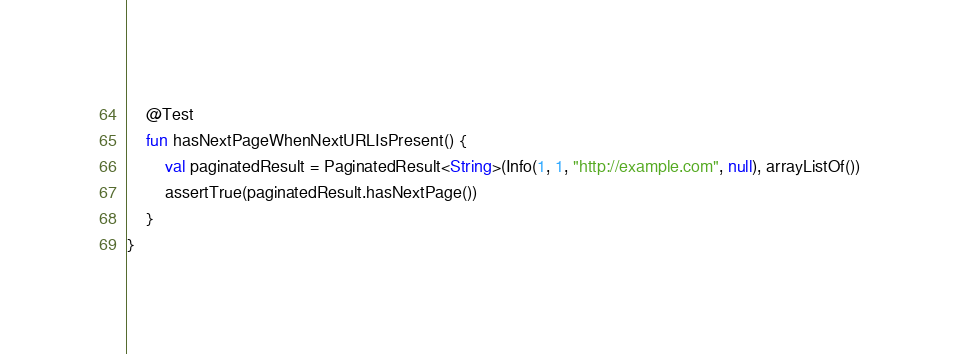Convert code to text. <code><loc_0><loc_0><loc_500><loc_500><_Kotlin_>
    @Test
    fun hasNextPageWhenNextURLIsPresent() {
        val paginatedResult = PaginatedResult<String>(Info(1, 1, "http://example.com", null), arrayListOf())
        assertTrue(paginatedResult.hasNextPage())
    }
}
</code> 